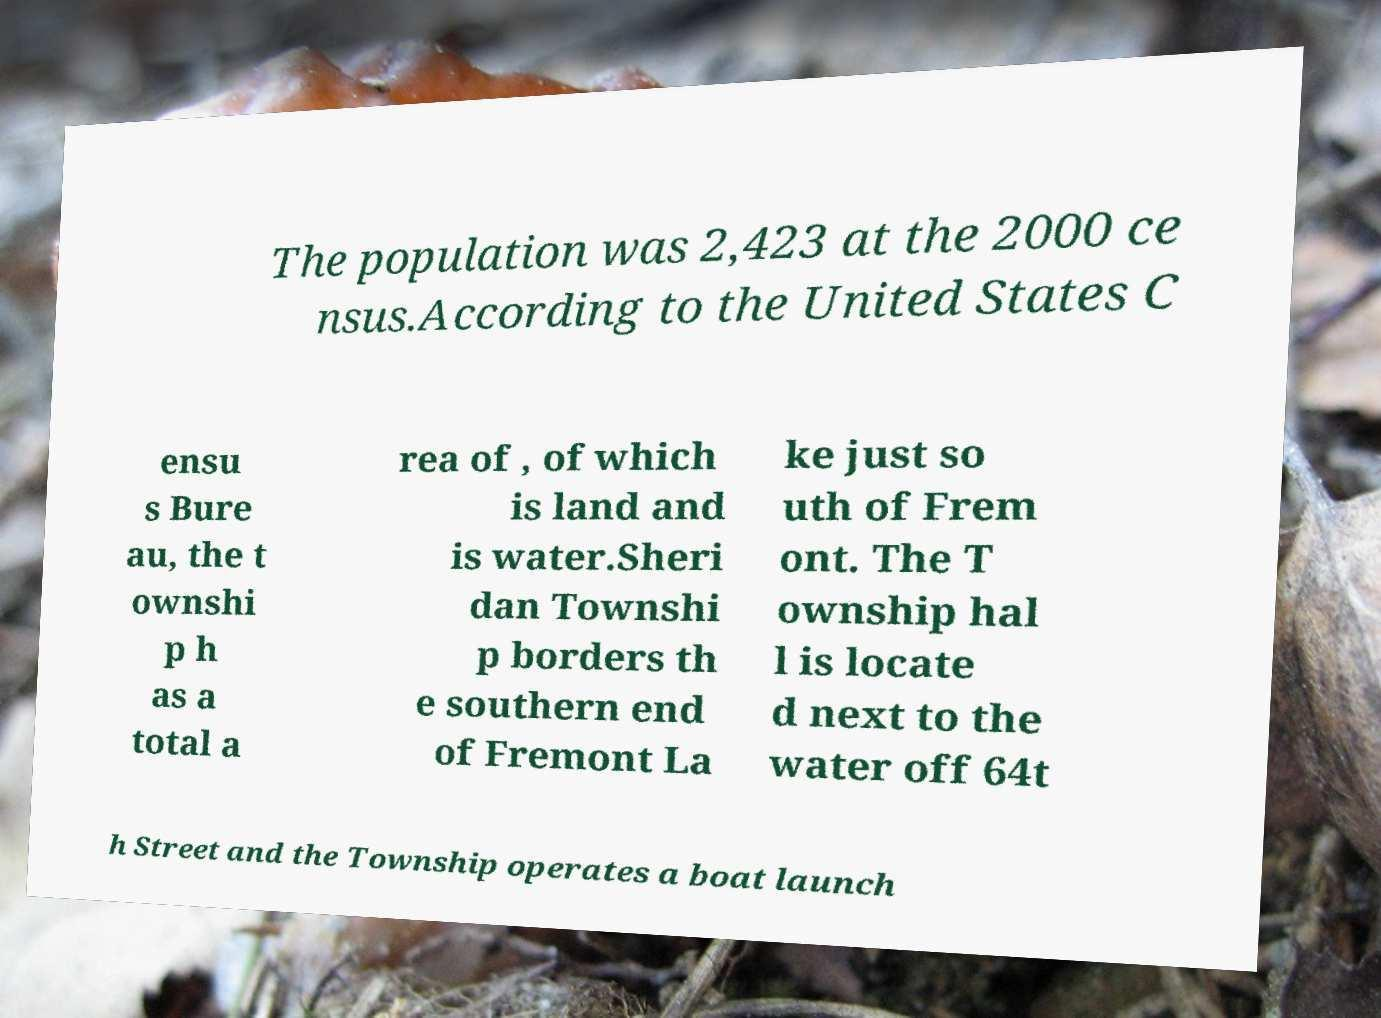I need the written content from this picture converted into text. Can you do that? The population was 2,423 at the 2000 ce nsus.According to the United States C ensu s Bure au, the t ownshi p h as a total a rea of , of which is land and is water.Sheri dan Townshi p borders th e southern end of Fremont La ke just so uth of Frem ont. The T ownship hal l is locate d next to the water off 64t h Street and the Township operates a boat launch 